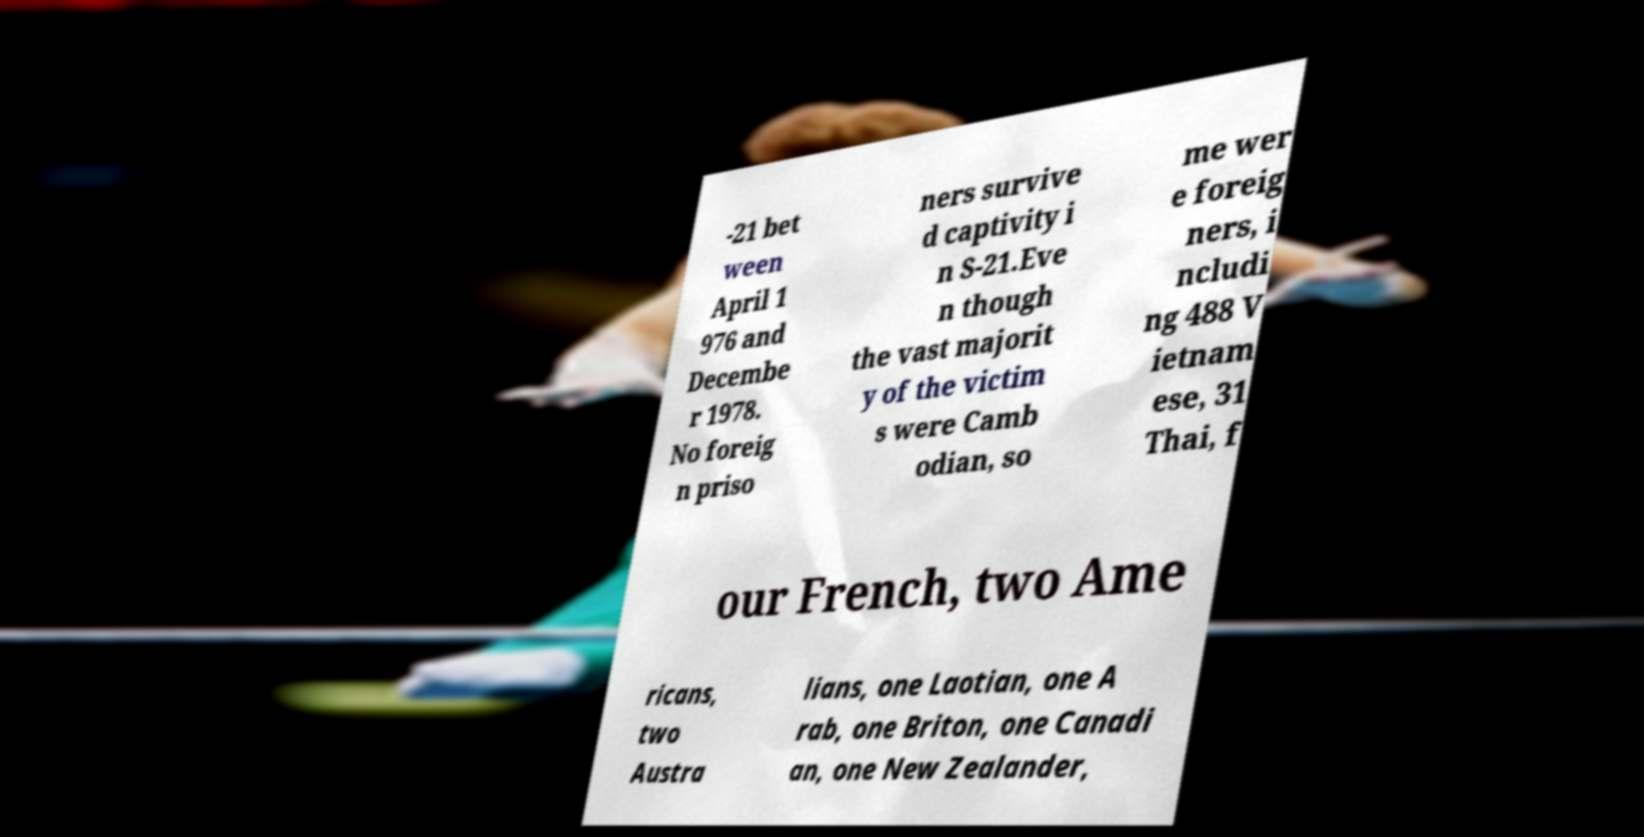Can you read and provide the text displayed in the image?This photo seems to have some interesting text. Can you extract and type it out for me? -21 bet ween April 1 976 and Decembe r 1978. No foreig n priso ners survive d captivity i n S-21.Eve n though the vast majorit y of the victim s were Camb odian, so me wer e foreig ners, i ncludi ng 488 V ietnam ese, 31 Thai, f our French, two Ame ricans, two Austra lians, one Laotian, one A rab, one Briton, one Canadi an, one New Zealander, 